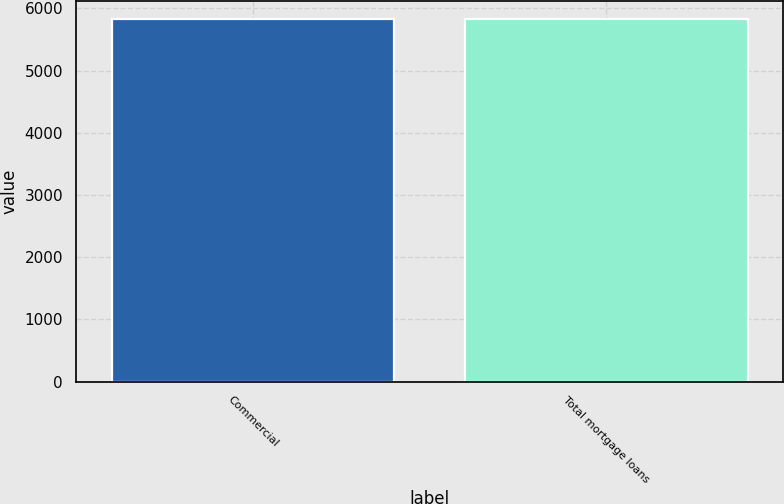<chart> <loc_0><loc_0><loc_500><loc_500><bar_chart><fcel>Commercial<fcel>Total mortgage loans<nl><fcel>5830<fcel>5830.1<nl></chart> 